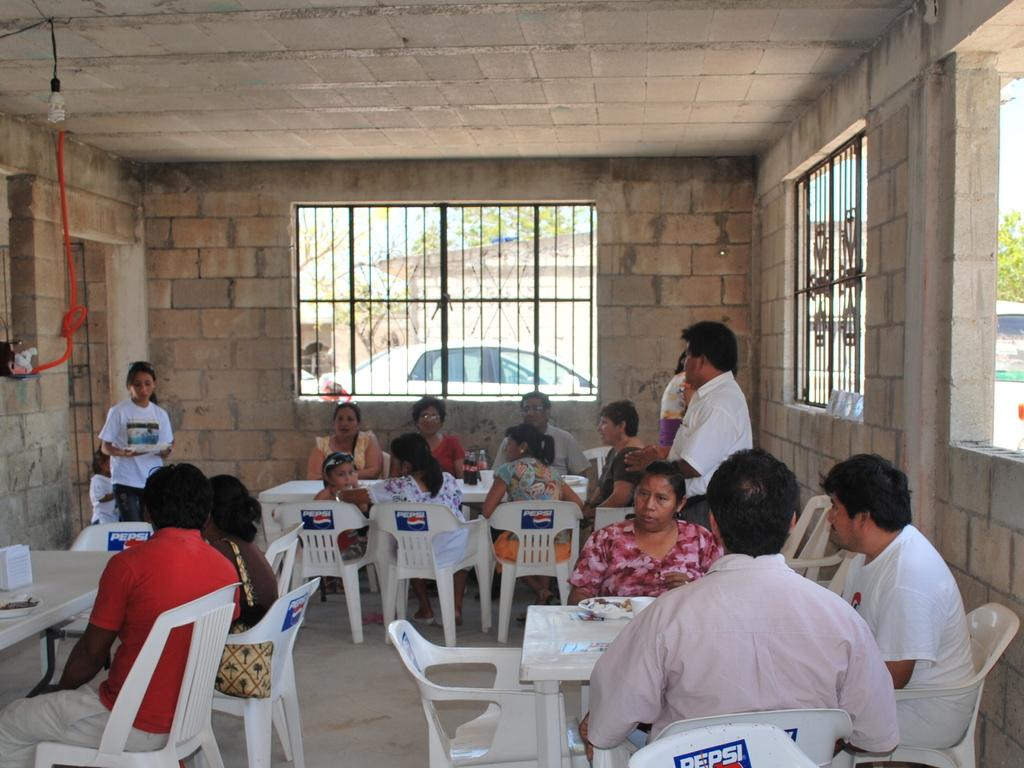How many people are in the image? There is a group of people in the image. What are the people doing in the image? The people are sitting on chairs and having food. What can be seen on the left side of the image? There is a car and a wall on the left side of the image. Is there any natural light source visible in the image? Yes, there is a window in the image. Where is the tub located in the image? There is no tub present in the image. What type of waste can be seen in the image? There is no waste visible in the image. 